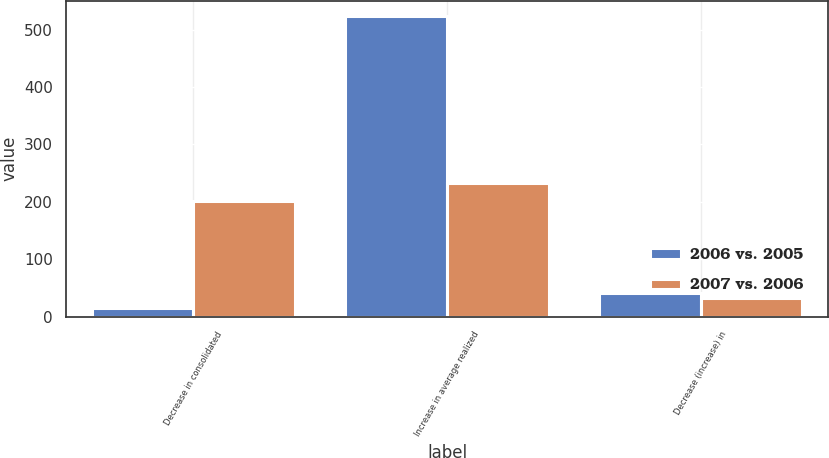<chart> <loc_0><loc_0><loc_500><loc_500><stacked_bar_chart><ecel><fcel>Decrease in consolidated<fcel>Increase in average realized<fcel>Decrease (increase) in<nl><fcel>2006 vs. 2005<fcel>15<fcel>524<fcel>41<nl><fcel>2007 vs. 2006<fcel>201<fcel>233<fcel>33<nl></chart> 